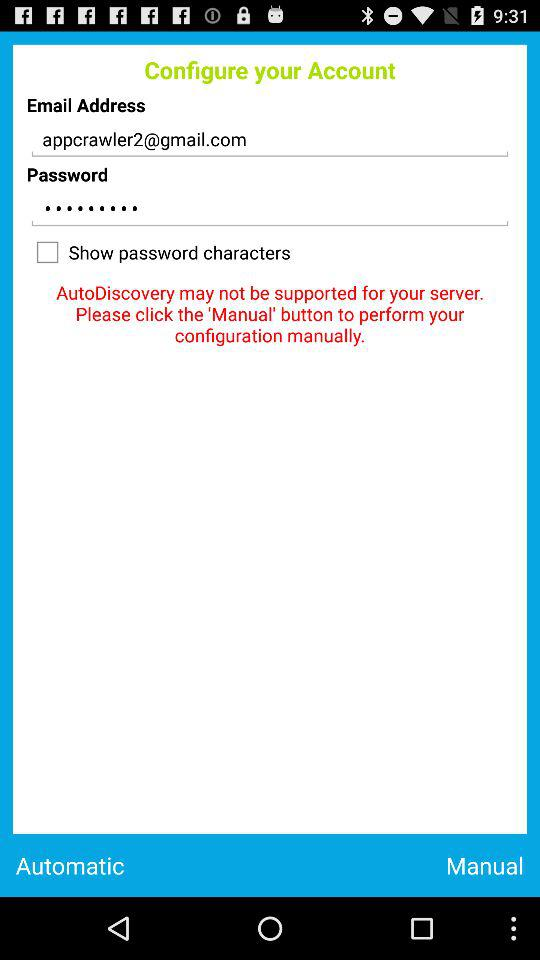What is the status of the "Show password characters"? The status is off. 